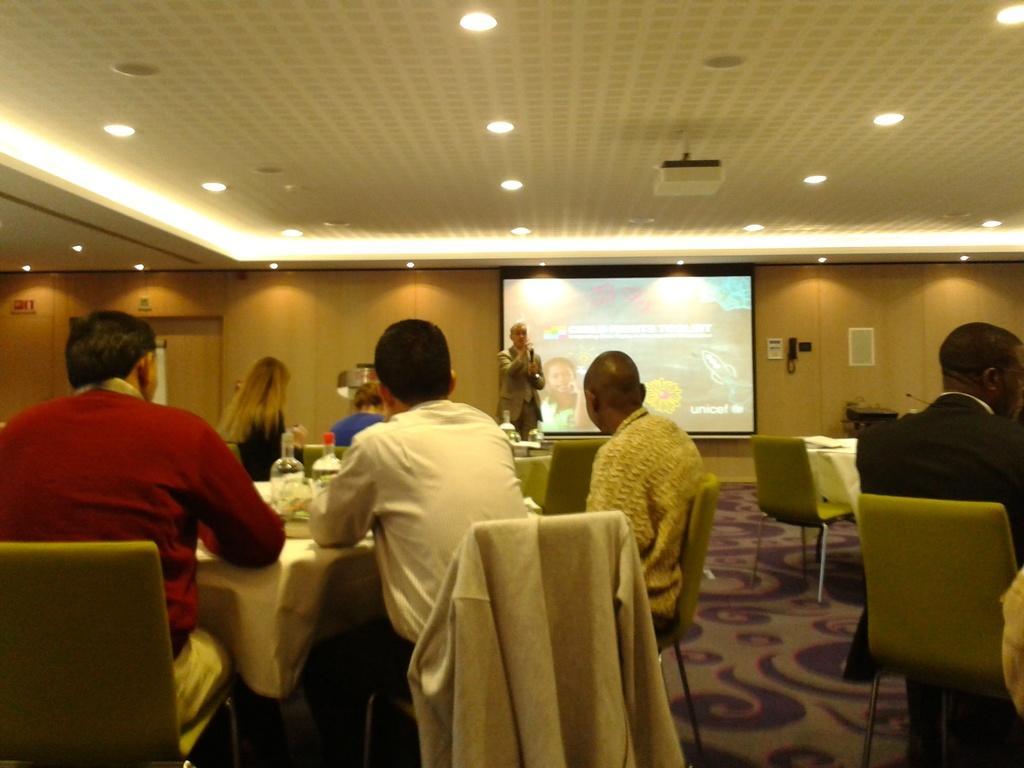Please provide a concise description of this image. On the left side a man is sitting on the chair, these are the dining tables. Few people are sitting, in the middle a man is speaking on the microphone and this is a projected screen. 